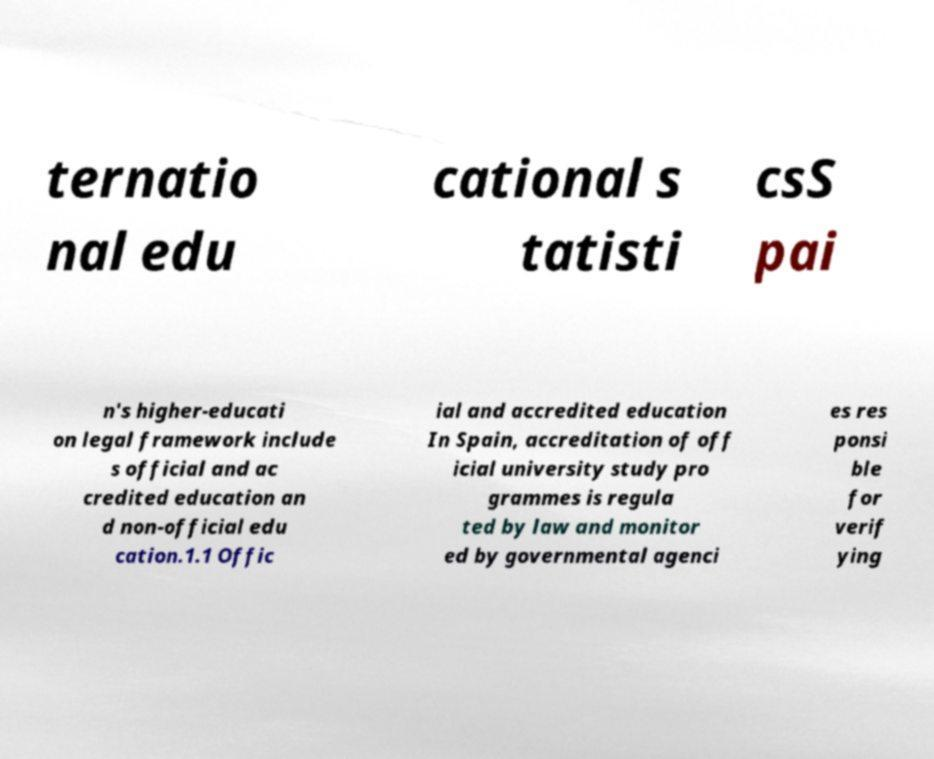What messages or text are displayed in this image? I need them in a readable, typed format. ternatio nal edu cational s tatisti csS pai n's higher-educati on legal framework include s official and ac credited education an d non-official edu cation.1.1 Offic ial and accredited education In Spain, accreditation of off icial university study pro grammes is regula ted by law and monitor ed by governmental agenci es res ponsi ble for verif ying 